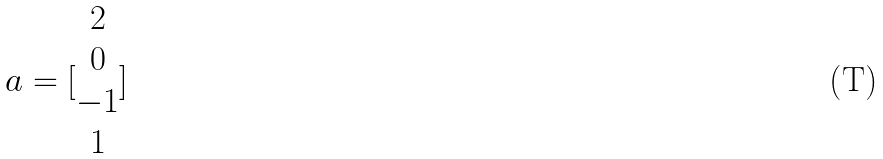<formula> <loc_0><loc_0><loc_500><loc_500>a = [ \begin{matrix} 2 \\ 0 \\ - 1 \\ 1 \end{matrix} ]</formula> 